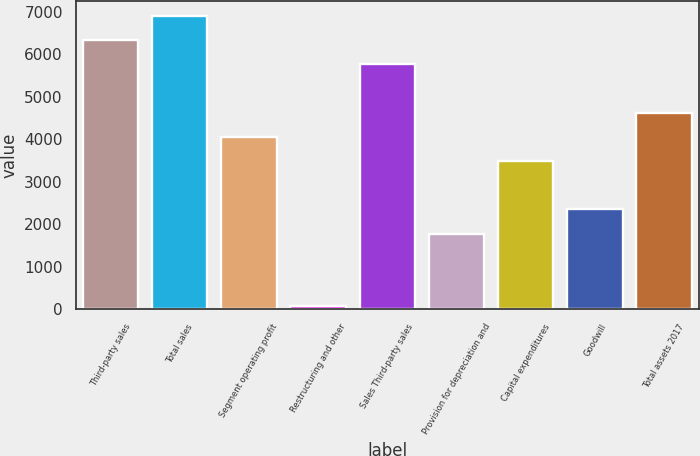Convert chart. <chart><loc_0><loc_0><loc_500><loc_500><bar_chart><fcel>Third-party sales<fcel>Total sales<fcel>Segment operating profit<fcel>Restructuring and other<fcel>Sales Third-party sales<fcel>Provision for depreciation and<fcel>Capital expenditures<fcel>Goodwill<fcel>Total assets 2017<nl><fcel>6333.2<fcel>6902.4<fcel>4056.4<fcel>72<fcel>5764<fcel>1779.6<fcel>3487.2<fcel>2348.8<fcel>4625.6<nl></chart> 